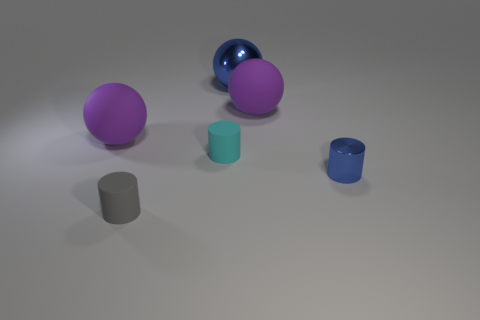There is a tiny cyan object; how many cyan matte things are in front of it?
Your answer should be very brief. 0. What is the shape of the purple matte object that is right of the rubber cylinder that is on the left side of the tiny cyan rubber cylinder?
Your answer should be very brief. Sphere. Is there any other thing that is the same shape as the cyan rubber thing?
Provide a short and direct response. Yes. Is the number of small cyan matte things that are to the left of the small blue metal thing greater than the number of green blocks?
Provide a short and direct response. Yes. How many blue metal things are behind the tiny gray matte thing to the left of the blue shiny sphere?
Offer a terse response. 2. What is the shape of the big purple matte object to the left of the tiny matte object in front of the shiny thing that is right of the shiny sphere?
Your answer should be compact. Sphere. What is the size of the cyan object?
Give a very brief answer. Small. Is there a cyan cylinder that has the same material as the tiny gray object?
Ensure brevity in your answer.  Yes. What is the size of the other matte object that is the same shape as the tiny gray rubber object?
Offer a terse response. Small. Is the number of gray matte cylinders in front of the small cyan rubber object the same as the number of large purple matte objects?
Your response must be concise. No. 